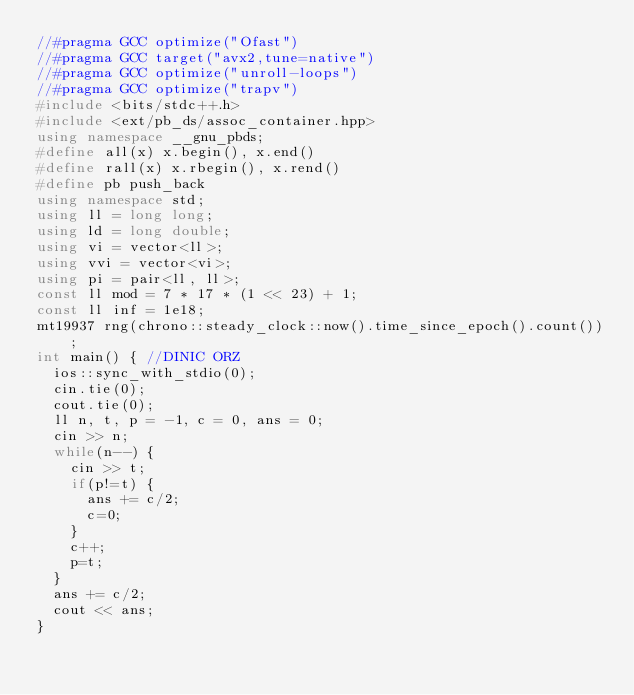Convert code to text. <code><loc_0><loc_0><loc_500><loc_500><_C++_>//#pragma GCC optimize("Ofast")
//#pragma GCC target("avx2,tune=native")
//#pragma GCC optimize("unroll-loops")
//#pragma GCC optimize("trapv")
#include <bits/stdc++.h>
#include <ext/pb_ds/assoc_container.hpp>
using namespace __gnu_pbds;
#define all(x) x.begin(), x.end()
#define rall(x) x.rbegin(), x.rend()
#define pb push_back
using namespace std;
using ll = long long;
using ld = long double;
using vi = vector<ll>;
using vvi = vector<vi>;
using pi = pair<ll, ll>;
const ll mod = 7 * 17 * (1 << 23) + 1;
const ll inf = 1e18;
mt19937 rng(chrono::steady_clock::now().time_since_epoch().count());
int main() { //DINIC ORZ
	ios::sync_with_stdio(0);
	cin.tie(0);
	cout.tie(0);
	ll n, t, p = -1, c = 0, ans = 0;
	cin >> n;
	while(n--) {
		cin >> t;
		if(p!=t) {
			ans += c/2;
			c=0;
		}
		c++;
		p=t;
	}
	ans += c/2;
	cout << ans;
}
</code> 